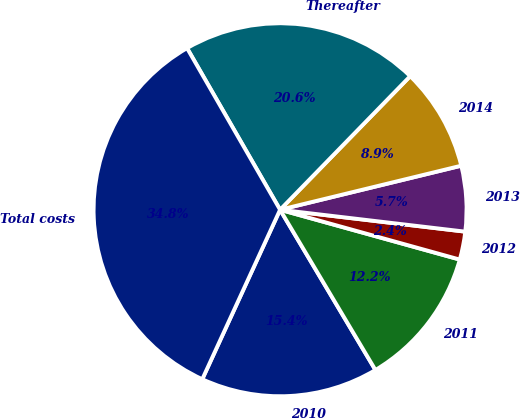<chart> <loc_0><loc_0><loc_500><loc_500><pie_chart><fcel>2010<fcel>2011<fcel>2012<fcel>2013<fcel>2014<fcel>Thereafter<fcel>Total costs<nl><fcel>15.39%<fcel>12.15%<fcel>2.43%<fcel>5.67%<fcel>8.91%<fcel>20.6%<fcel>34.83%<nl></chart> 